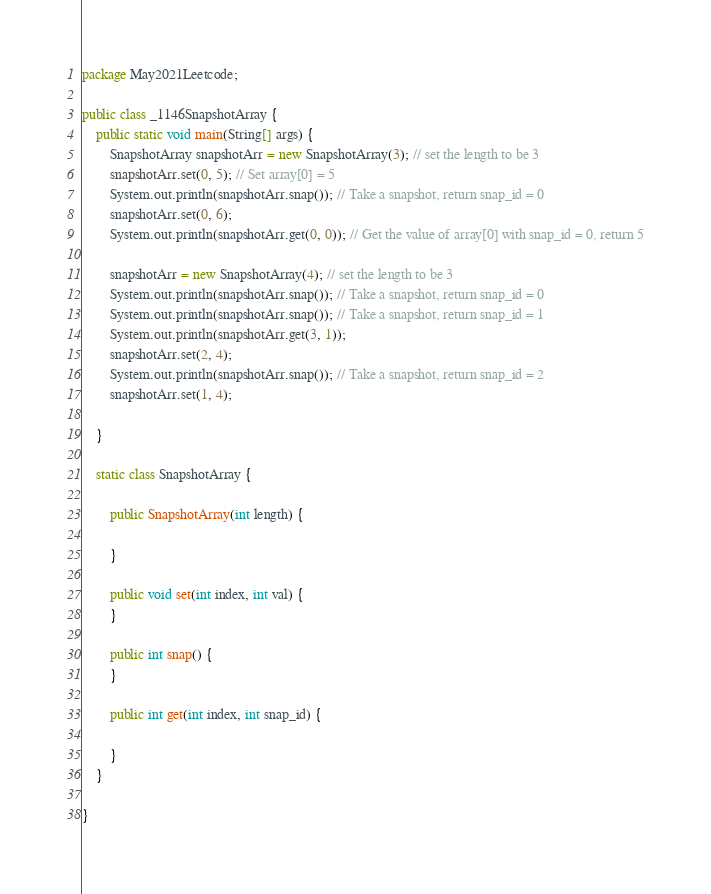<code> <loc_0><loc_0><loc_500><loc_500><_Java_>package May2021Leetcode;

public class _1146SnapshotArray {
	public static void main(String[] args) {
		SnapshotArray snapshotArr = new SnapshotArray(3); // set the length to be 3
		snapshotArr.set(0, 5); // Set array[0] = 5
		System.out.println(snapshotArr.snap()); // Take a snapshot, return snap_id = 0
		snapshotArr.set(0, 6);
		System.out.println(snapshotArr.get(0, 0)); // Get the value of array[0] with snap_id = 0, return 5

		snapshotArr = new SnapshotArray(4); // set the length to be 3
		System.out.println(snapshotArr.snap()); // Take a snapshot, return snap_id = 0
		System.out.println(snapshotArr.snap()); // Take a snapshot, return snap_id = 1
		System.out.println(snapshotArr.get(3, 1));
		snapshotArr.set(2, 4);
		System.out.println(snapshotArr.snap()); // Take a snapshot, return snap_id = 2
		snapshotArr.set(1, 4);

	}

	static class SnapshotArray {

		public SnapshotArray(int length) {

		}

		public void set(int index, int val) {
		}

		public int snap() {
		}

		public int get(int index, int snap_id) {

		}
	}

}
</code> 